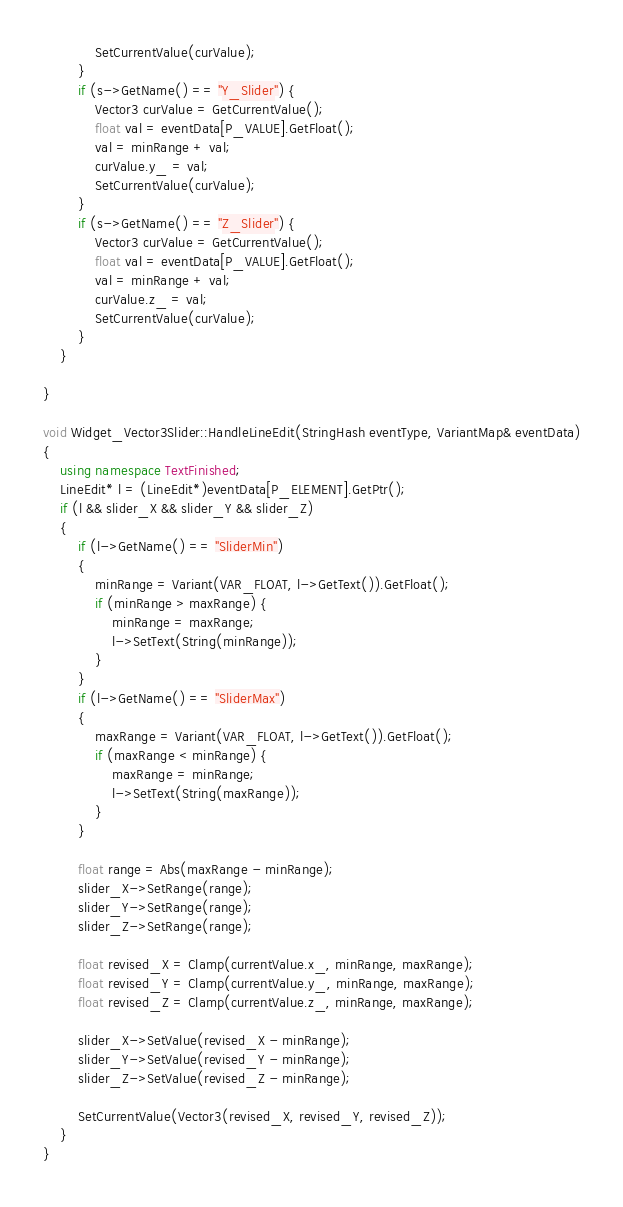Convert code to text. <code><loc_0><loc_0><loc_500><loc_500><_C++_>			SetCurrentValue(curValue);
		}
		if (s->GetName() == "Y_Slider") {
			Vector3 curValue = GetCurrentValue();
			float val = eventData[P_VALUE].GetFloat();
			val = minRange + val;
			curValue.y_ = val;
			SetCurrentValue(curValue);
		}
		if (s->GetName() == "Z_Slider") {
			Vector3 curValue = GetCurrentValue();
			float val = eventData[P_VALUE].GetFloat();
			val = minRange + val;
			curValue.z_ = val;
			SetCurrentValue(curValue);
		}
	}

}

void Widget_Vector3Slider::HandleLineEdit(StringHash eventType, VariantMap& eventData)
{
	using namespace TextFinished;
	LineEdit* l = (LineEdit*)eventData[P_ELEMENT].GetPtr();
	if (l && slider_X && slider_Y && slider_Z)
	{
		if (l->GetName() == "SliderMin")
		{
			minRange = Variant(VAR_FLOAT, l->GetText()).GetFloat();
			if (minRange > maxRange) {
				minRange = maxRange;
				l->SetText(String(minRange));
			}
		}
		if (l->GetName() == "SliderMax")
		{
			maxRange = Variant(VAR_FLOAT, l->GetText()).GetFloat();
			if (maxRange < minRange) {
				maxRange = minRange;
				l->SetText(String(maxRange));
			}
		}

		float range = Abs(maxRange - minRange);
		slider_X->SetRange(range);
		slider_Y->SetRange(range);
		slider_Z->SetRange(range);

		float revised_X = Clamp(currentValue.x_, minRange, maxRange);
		float revised_Y = Clamp(currentValue.y_, minRange, maxRange);
		float revised_Z = Clamp(currentValue.z_, minRange, maxRange);

		slider_X->SetValue(revised_X - minRange);
		slider_Y->SetValue(revised_Y - minRange);
		slider_Z->SetValue(revised_Z - minRange);

		SetCurrentValue(Vector3(revised_X, revised_Y, revised_Z));
	}
}</code> 